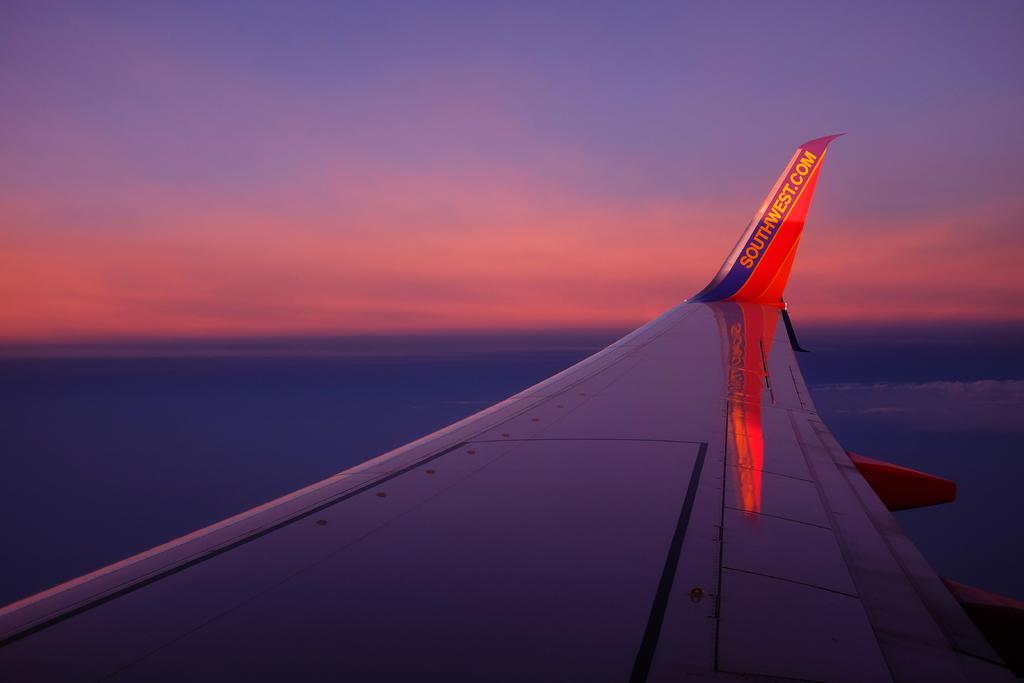<image>
Relay a brief, clear account of the picture shown. If you want to know more about this airline, go to southwest.com. 